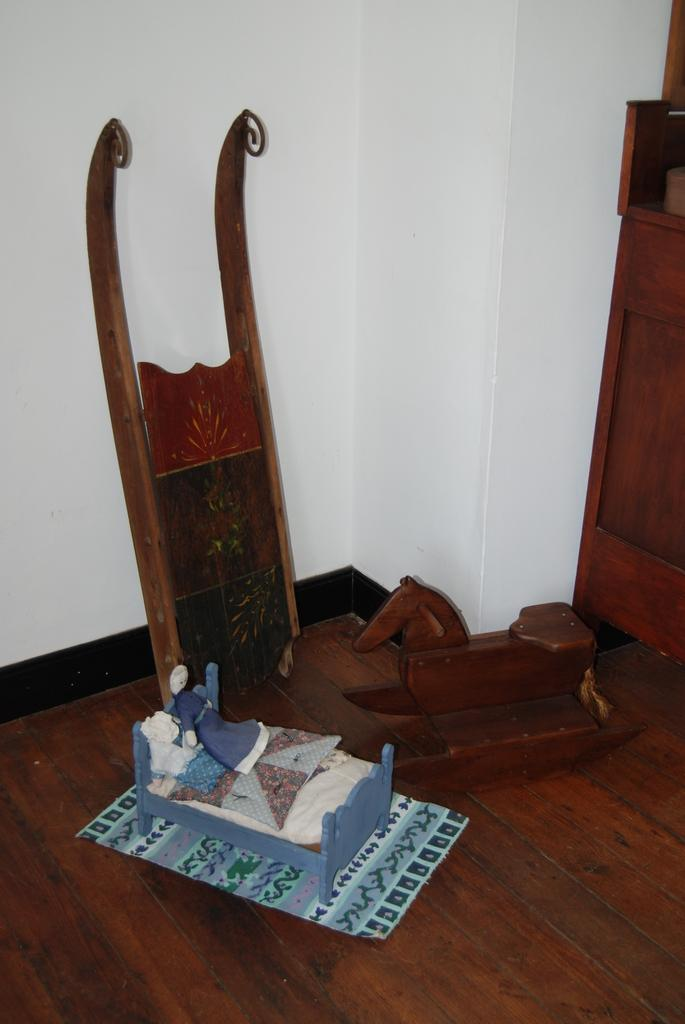What objects can be seen on the bed in the image? There are toys on the bed. What is present on the wall in the background of the image? There is a poster visible in the image. What type of objects can be seen on the wooden floor? There are wooden objects on the wooden floor. What can be seen in the background of the image? There is a wall visible in the background of the image. What flavor of cat can be seen in the image? There is no cat present in the image, and therefore no flavor can be associated with it. What team is represented by the wooden objects on the wooden floor? The wooden objects on the wooden floor do not represent any team; they are simply wooden objects. 